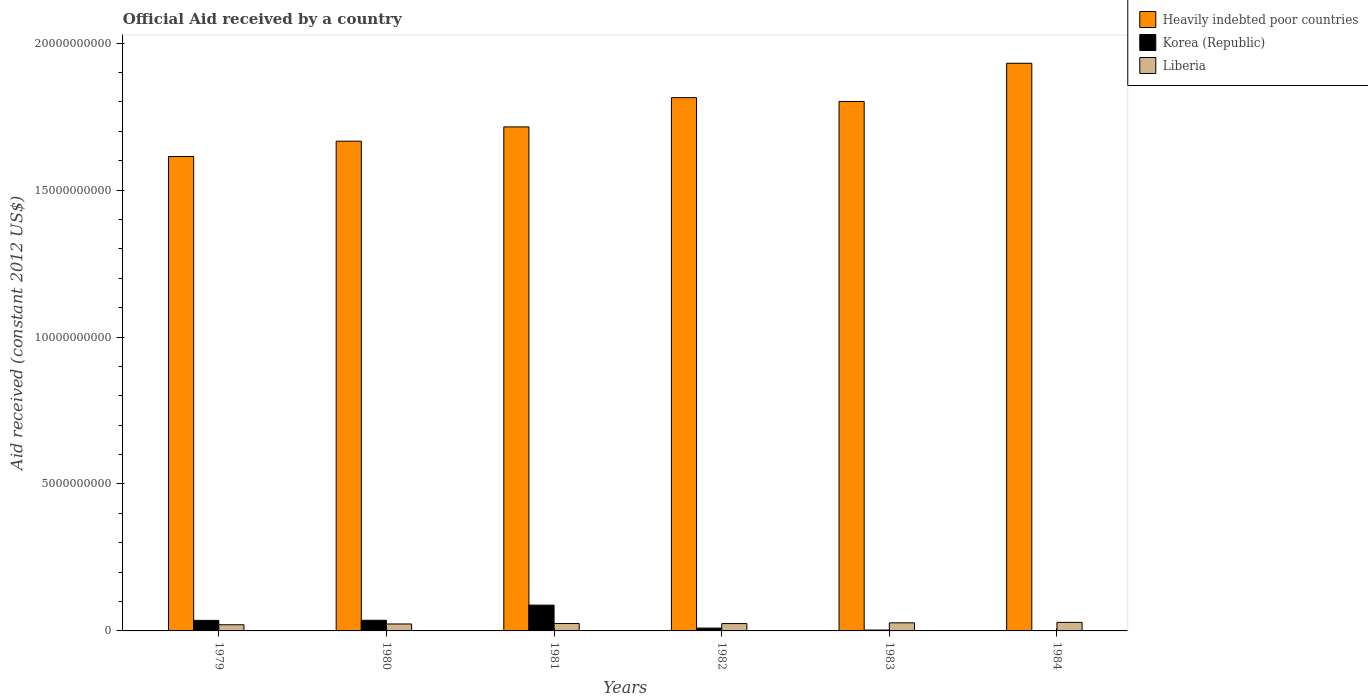How many groups of bars are there?
Provide a succinct answer. 6. Are the number of bars per tick equal to the number of legend labels?
Offer a very short reply. No. Are the number of bars on each tick of the X-axis equal?
Your answer should be compact. No. What is the net official aid received in Korea (Republic) in 1979?
Provide a succinct answer. 3.59e+08. Across all years, what is the maximum net official aid received in Heavily indebted poor countries?
Give a very brief answer. 1.93e+1. Across all years, what is the minimum net official aid received in Liberia?
Your answer should be compact. 2.09e+08. In which year was the net official aid received in Korea (Republic) maximum?
Make the answer very short. 1981. What is the total net official aid received in Heavily indebted poor countries in the graph?
Offer a very short reply. 1.05e+11. What is the difference between the net official aid received in Korea (Republic) in 1979 and that in 1980?
Your answer should be compact. -3.07e+06. What is the difference between the net official aid received in Korea (Republic) in 1981 and the net official aid received in Liberia in 1983?
Provide a short and direct response. 6.03e+08. What is the average net official aid received in Liberia per year?
Ensure brevity in your answer.  2.52e+08. In the year 1979, what is the difference between the net official aid received in Liberia and net official aid received in Korea (Republic)?
Make the answer very short. -1.50e+08. In how many years, is the net official aid received in Korea (Republic) greater than 15000000000 US$?
Your answer should be very brief. 0. What is the ratio of the net official aid received in Heavily indebted poor countries in 1979 to that in 1982?
Provide a short and direct response. 0.89. Is the net official aid received in Korea (Republic) in 1981 less than that in 1982?
Provide a short and direct response. No. Is the difference between the net official aid received in Liberia in 1980 and 1982 greater than the difference between the net official aid received in Korea (Republic) in 1980 and 1982?
Your response must be concise. No. What is the difference between the highest and the second highest net official aid received in Korea (Republic)?
Give a very brief answer. 5.16e+08. What is the difference between the highest and the lowest net official aid received in Korea (Republic)?
Provide a short and direct response. 8.78e+08. Is it the case that in every year, the sum of the net official aid received in Liberia and net official aid received in Korea (Republic) is greater than the net official aid received in Heavily indebted poor countries?
Give a very brief answer. No. How many bars are there?
Keep it short and to the point. 17. Are all the bars in the graph horizontal?
Offer a terse response. No. What is the difference between two consecutive major ticks on the Y-axis?
Give a very brief answer. 5.00e+09. How many legend labels are there?
Keep it short and to the point. 3. How are the legend labels stacked?
Your answer should be compact. Vertical. What is the title of the graph?
Provide a succinct answer. Official Aid received by a country. What is the label or title of the X-axis?
Keep it short and to the point. Years. What is the label or title of the Y-axis?
Offer a very short reply. Aid received (constant 2012 US$). What is the Aid received (constant 2012 US$) in Heavily indebted poor countries in 1979?
Offer a terse response. 1.61e+1. What is the Aid received (constant 2012 US$) in Korea (Republic) in 1979?
Offer a very short reply. 3.59e+08. What is the Aid received (constant 2012 US$) in Liberia in 1979?
Offer a very short reply. 2.09e+08. What is the Aid received (constant 2012 US$) in Heavily indebted poor countries in 1980?
Ensure brevity in your answer.  1.67e+1. What is the Aid received (constant 2012 US$) in Korea (Republic) in 1980?
Offer a very short reply. 3.62e+08. What is the Aid received (constant 2012 US$) of Liberia in 1980?
Your answer should be very brief. 2.36e+08. What is the Aid received (constant 2012 US$) in Heavily indebted poor countries in 1981?
Make the answer very short. 1.71e+1. What is the Aid received (constant 2012 US$) of Korea (Republic) in 1981?
Your response must be concise. 8.78e+08. What is the Aid received (constant 2012 US$) of Liberia in 1981?
Your answer should be compact. 2.51e+08. What is the Aid received (constant 2012 US$) of Heavily indebted poor countries in 1982?
Make the answer very short. 1.81e+1. What is the Aid received (constant 2012 US$) in Korea (Republic) in 1982?
Keep it short and to the point. 9.64e+07. What is the Aid received (constant 2012 US$) in Liberia in 1982?
Provide a short and direct response. 2.50e+08. What is the Aid received (constant 2012 US$) in Heavily indebted poor countries in 1983?
Your answer should be compact. 1.80e+1. What is the Aid received (constant 2012 US$) of Korea (Republic) in 1983?
Offer a terse response. 2.93e+07. What is the Aid received (constant 2012 US$) in Liberia in 1983?
Keep it short and to the point. 2.75e+08. What is the Aid received (constant 2012 US$) in Heavily indebted poor countries in 1984?
Keep it short and to the point. 1.93e+1. What is the Aid received (constant 2012 US$) in Liberia in 1984?
Offer a very short reply. 2.91e+08. Across all years, what is the maximum Aid received (constant 2012 US$) in Heavily indebted poor countries?
Give a very brief answer. 1.93e+1. Across all years, what is the maximum Aid received (constant 2012 US$) of Korea (Republic)?
Provide a short and direct response. 8.78e+08. Across all years, what is the maximum Aid received (constant 2012 US$) in Liberia?
Offer a very short reply. 2.91e+08. Across all years, what is the minimum Aid received (constant 2012 US$) of Heavily indebted poor countries?
Provide a succinct answer. 1.61e+1. Across all years, what is the minimum Aid received (constant 2012 US$) of Liberia?
Offer a very short reply. 2.09e+08. What is the total Aid received (constant 2012 US$) of Heavily indebted poor countries in the graph?
Provide a short and direct response. 1.05e+11. What is the total Aid received (constant 2012 US$) of Korea (Republic) in the graph?
Provide a short and direct response. 1.72e+09. What is the total Aid received (constant 2012 US$) of Liberia in the graph?
Ensure brevity in your answer.  1.51e+09. What is the difference between the Aid received (constant 2012 US$) in Heavily indebted poor countries in 1979 and that in 1980?
Your answer should be compact. -5.23e+08. What is the difference between the Aid received (constant 2012 US$) of Korea (Republic) in 1979 and that in 1980?
Provide a succinct answer. -3.07e+06. What is the difference between the Aid received (constant 2012 US$) of Liberia in 1979 and that in 1980?
Provide a short and direct response. -2.69e+07. What is the difference between the Aid received (constant 2012 US$) in Heavily indebted poor countries in 1979 and that in 1981?
Provide a short and direct response. -1.01e+09. What is the difference between the Aid received (constant 2012 US$) of Korea (Republic) in 1979 and that in 1981?
Offer a terse response. -5.19e+08. What is the difference between the Aid received (constant 2012 US$) of Liberia in 1979 and that in 1981?
Your answer should be very brief. -4.21e+07. What is the difference between the Aid received (constant 2012 US$) of Heavily indebted poor countries in 1979 and that in 1982?
Offer a terse response. -2.00e+09. What is the difference between the Aid received (constant 2012 US$) in Korea (Republic) in 1979 and that in 1982?
Make the answer very short. 2.63e+08. What is the difference between the Aid received (constant 2012 US$) of Liberia in 1979 and that in 1982?
Offer a very short reply. -4.05e+07. What is the difference between the Aid received (constant 2012 US$) in Heavily indebted poor countries in 1979 and that in 1983?
Offer a very short reply. -1.87e+09. What is the difference between the Aid received (constant 2012 US$) of Korea (Republic) in 1979 and that in 1983?
Ensure brevity in your answer.  3.30e+08. What is the difference between the Aid received (constant 2012 US$) of Liberia in 1979 and that in 1983?
Provide a succinct answer. -6.59e+07. What is the difference between the Aid received (constant 2012 US$) in Heavily indebted poor countries in 1979 and that in 1984?
Provide a succinct answer. -3.17e+09. What is the difference between the Aid received (constant 2012 US$) in Liberia in 1979 and that in 1984?
Provide a succinct answer. -8.14e+07. What is the difference between the Aid received (constant 2012 US$) in Heavily indebted poor countries in 1980 and that in 1981?
Your answer should be compact. -4.85e+08. What is the difference between the Aid received (constant 2012 US$) in Korea (Republic) in 1980 and that in 1981?
Your answer should be very brief. -5.16e+08. What is the difference between the Aid received (constant 2012 US$) of Liberia in 1980 and that in 1981?
Your answer should be very brief. -1.52e+07. What is the difference between the Aid received (constant 2012 US$) of Heavily indebted poor countries in 1980 and that in 1982?
Provide a succinct answer. -1.48e+09. What is the difference between the Aid received (constant 2012 US$) of Korea (Republic) in 1980 and that in 1982?
Your answer should be compact. 2.66e+08. What is the difference between the Aid received (constant 2012 US$) in Liberia in 1980 and that in 1982?
Give a very brief answer. -1.35e+07. What is the difference between the Aid received (constant 2012 US$) of Heavily indebted poor countries in 1980 and that in 1983?
Ensure brevity in your answer.  -1.35e+09. What is the difference between the Aid received (constant 2012 US$) of Korea (Republic) in 1980 and that in 1983?
Provide a succinct answer. 3.33e+08. What is the difference between the Aid received (constant 2012 US$) of Liberia in 1980 and that in 1983?
Your answer should be very brief. -3.89e+07. What is the difference between the Aid received (constant 2012 US$) of Heavily indebted poor countries in 1980 and that in 1984?
Keep it short and to the point. -2.65e+09. What is the difference between the Aid received (constant 2012 US$) in Liberia in 1980 and that in 1984?
Your answer should be compact. -5.45e+07. What is the difference between the Aid received (constant 2012 US$) in Heavily indebted poor countries in 1981 and that in 1982?
Your answer should be compact. -9.95e+08. What is the difference between the Aid received (constant 2012 US$) in Korea (Republic) in 1981 and that in 1982?
Ensure brevity in your answer.  7.81e+08. What is the difference between the Aid received (constant 2012 US$) in Liberia in 1981 and that in 1982?
Provide a short and direct response. 1.65e+06. What is the difference between the Aid received (constant 2012 US$) of Heavily indebted poor countries in 1981 and that in 1983?
Offer a very short reply. -8.65e+08. What is the difference between the Aid received (constant 2012 US$) in Korea (Republic) in 1981 and that in 1983?
Ensure brevity in your answer.  8.49e+08. What is the difference between the Aid received (constant 2012 US$) of Liberia in 1981 and that in 1983?
Provide a short and direct response. -2.38e+07. What is the difference between the Aid received (constant 2012 US$) of Heavily indebted poor countries in 1981 and that in 1984?
Give a very brief answer. -2.17e+09. What is the difference between the Aid received (constant 2012 US$) of Liberia in 1981 and that in 1984?
Offer a very short reply. -3.93e+07. What is the difference between the Aid received (constant 2012 US$) of Heavily indebted poor countries in 1982 and that in 1983?
Provide a succinct answer. 1.30e+08. What is the difference between the Aid received (constant 2012 US$) in Korea (Republic) in 1982 and that in 1983?
Ensure brevity in your answer.  6.71e+07. What is the difference between the Aid received (constant 2012 US$) in Liberia in 1982 and that in 1983?
Your answer should be very brief. -2.54e+07. What is the difference between the Aid received (constant 2012 US$) in Heavily indebted poor countries in 1982 and that in 1984?
Your answer should be compact. -1.17e+09. What is the difference between the Aid received (constant 2012 US$) of Liberia in 1982 and that in 1984?
Your answer should be very brief. -4.09e+07. What is the difference between the Aid received (constant 2012 US$) in Heavily indebted poor countries in 1983 and that in 1984?
Offer a terse response. -1.30e+09. What is the difference between the Aid received (constant 2012 US$) in Liberia in 1983 and that in 1984?
Your response must be concise. -1.55e+07. What is the difference between the Aid received (constant 2012 US$) of Heavily indebted poor countries in 1979 and the Aid received (constant 2012 US$) of Korea (Republic) in 1980?
Offer a very short reply. 1.58e+1. What is the difference between the Aid received (constant 2012 US$) in Heavily indebted poor countries in 1979 and the Aid received (constant 2012 US$) in Liberia in 1980?
Offer a terse response. 1.59e+1. What is the difference between the Aid received (constant 2012 US$) in Korea (Republic) in 1979 and the Aid received (constant 2012 US$) in Liberia in 1980?
Provide a short and direct response. 1.23e+08. What is the difference between the Aid received (constant 2012 US$) of Heavily indebted poor countries in 1979 and the Aid received (constant 2012 US$) of Korea (Republic) in 1981?
Ensure brevity in your answer.  1.53e+1. What is the difference between the Aid received (constant 2012 US$) in Heavily indebted poor countries in 1979 and the Aid received (constant 2012 US$) in Liberia in 1981?
Provide a succinct answer. 1.59e+1. What is the difference between the Aid received (constant 2012 US$) of Korea (Republic) in 1979 and the Aid received (constant 2012 US$) of Liberia in 1981?
Provide a succinct answer. 1.08e+08. What is the difference between the Aid received (constant 2012 US$) of Heavily indebted poor countries in 1979 and the Aid received (constant 2012 US$) of Korea (Republic) in 1982?
Your answer should be compact. 1.60e+1. What is the difference between the Aid received (constant 2012 US$) in Heavily indebted poor countries in 1979 and the Aid received (constant 2012 US$) in Liberia in 1982?
Ensure brevity in your answer.  1.59e+1. What is the difference between the Aid received (constant 2012 US$) in Korea (Republic) in 1979 and the Aid received (constant 2012 US$) in Liberia in 1982?
Make the answer very short. 1.09e+08. What is the difference between the Aid received (constant 2012 US$) of Heavily indebted poor countries in 1979 and the Aid received (constant 2012 US$) of Korea (Republic) in 1983?
Offer a very short reply. 1.61e+1. What is the difference between the Aid received (constant 2012 US$) in Heavily indebted poor countries in 1979 and the Aid received (constant 2012 US$) in Liberia in 1983?
Keep it short and to the point. 1.59e+1. What is the difference between the Aid received (constant 2012 US$) in Korea (Republic) in 1979 and the Aid received (constant 2012 US$) in Liberia in 1983?
Keep it short and to the point. 8.39e+07. What is the difference between the Aid received (constant 2012 US$) in Heavily indebted poor countries in 1979 and the Aid received (constant 2012 US$) in Liberia in 1984?
Your answer should be very brief. 1.58e+1. What is the difference between the Aid received (constant 2012 US$) of Korea (Republic) in 1979 and the Aid received (constant 2012 US$) of Liberia in 1984?
Offer a very short reply. 6.84e+07. What is the difference between the Aid received (constant 2012 US$) in Heavily indebted poor countries in 1980 and the Aid received (constant 2012 US$) in Korea (Republic) in 1981?
Your answer should be compact. 1.58e+1. What is the difference between the Aid received (constant 2012 US$) in Heavily indebted poor countries in 1980 and the Aid received (constant 2012 US$) in Liberia in 1981?
Ensure brevity in your answer.  1.64e+1. What is the difference between the Aid received (constant 2012 US$) in Korea (Republic) in 1980 and the Aid received (constant 2012 US$) in Liberia in 1981?
Your response must be concise. 1.11e+08. What is the difference between the Aid received (constant 2012 US$) in Heavily indebted poor countries in 1980 and the Aid received (constant 2012 US$) in Korea (Republic) in 1982?
Your response must be concise. 1.66e+1. What is the difference between the Aid received (constant 2012 US$) in Heavily indebted poor countries in 1980 and the Aid received (constant 2012 US$) in Liberia in 1982?
Your response must be concise. 1.64e+1. What is the difference between the Aid received (constant 2012 US$) in Korea (Republic) in 1980 and the Aid received (constant 2012 US$) in Liberia in 1982?
Your answer should be very brief. 1.12e+08. What is the difference between the Aid received (constant 2012 US$) in Heavily indebted poor countries in 1980 and the Aid received (constant 2012 US$) in Korea (Republic) in 1983?
Provide a short and direct response. 1.66e+1. What is the difference between the Aid received (constant 2012 US$) of Heavily indebted poor countries in 1980 and the Aid received (constant 2012 US$) of Liberia in 1983?
Your answer should be compact. 1.64e+1. What is the difference between the Aid received (constant 2012 US$) in Korea (Republic) in 1980 and the Aid received (constant 2012 US$) in Liberia in 1983?
Ensure brevity in your answer.  8.70e+07. What is the difference between the Aid received (constant 2012 US$) of Heavily indebted poor countries in 1980 and the Aid received (constant 2012 US$) of Liberia in 1984?
Your answer should be compact. 1.64e+1. What is the difference between the Aid received (constant 2012 US$) of Korea (Republic) in 1980 and the Aid received (constant 2012 US$) of Liberia in 1984?
Offer a terse response. 7.15e+07. What is the difference between the Aid received (constant 2012 US$) of Heavily indebted poor countries in 1981 and the Aid received (constant 2012 US$) of Korea (Republic) in 1982?
Provide a succinct answer. 1.71e+1. What is the difference between the Aid received (constant 2012 US$) of Heavily indebted poor countries in 1981 and the Aid received (constant 2012 US$) of Liberia in 1982?
Offer a terse response. 1.69e+1. What is the difference between the Aid received (constant 2012 US$) of Korea (Republic) in 1981 and the Aid received (constant 2012 US$) of Liberia in 1982?
Provide a succinct answer. 6.28e+08. What is the difference between the Aid received (constant 2012 US$) of Heavily indebted poor countries in 1981 and the Aid received (constant 2012 US$) of Korea (Republic) in 1983?
Offer a very short reply. 1.71e+1. What is the difference between the Aid received (constant 2012 US$) of Heavily indebted poor countries in 1981 and the Aid received (constant 2012 US$) of Liberia in 1983?
Make the answer very short. 1.69e+1. What is the difference between the Aid received (constant 2012 US$) of Korea (Republic) in 1981 and the Aid received (constant 2012 US$) of Liberia in 1983?
Your response must be concise. 6.03e+08. What is the difference between the Aid received (constant 2012 US$) in Heavily indebted poor countries in 1981 and the Aid received (constant 2012 US$) in Liberia in 1984?
Ensure brevity in your answer.  1.69e+1. What is the difference between the Aid received (constant 2012 US$) of Korea (Republic) in 1981 and the Aid received (constant 2012 US$) of Liberia in 1984?
Give a very brief answer. 5.87e+08. What is the difference between the Aid received (constant 2012 US$) in Heavily indebted poor countries in 1982 and the Aid received (constant 2012 US$) in Korea (Republic) in 1983?
Provide a succinct answer. 1.81e+1. What is the difference between the Aid received (constant 2012 US$) of Heavily indebted poor countries in 1982 and the Aid received (constant 2012 US$) of Liberia in 1983?
Offer a terse response. 1.79e+1. What is the difference between the Aid received (constant 2012 US$) of Korea (Republic) in 1982 and the Aid received (constant 2012 US$) of Liberia in 1983?
Your answer should be very brief. -1.79e+08. What is the difference between the Aid received (constant 2012 US$) in Heavily indebted poor countries in 1982 and the Aid received (constant 2012 US$) in Liberia in 1984?
Your answer should be very brief. 1.79e+1. What is the difference between the Aid received (constant 2012 US$) in Korea (Republic) in 1982 and the Aid received (constant 2012 US$) in Liberia in 1984?
Your response must be concise. -1.94e+08. What is the difference between the Aid received (constant 2012 US$) in Heavily indebted poor countries in 1983 and the Aid received (constant 2012 US$) in Liberia in 1984?
Ensure brevity in your answer.  1.77e+1. What is the difference between the Aid received (constant 2012 US$) of Korea (Republic) in 1983 and the Aid received (constant 2012 US$) of Liberia in 1984?
Ensure brevity in your answer.  -2.61e+08. What is the average Aid received (constant 2012 US$) in Heavily indebted poor countries per year?
Ensure brevity in your answer.  1.76e+1. What is the average Aid received (constant 2012 US$) in Korea (Republic) per year?
Give a very brief answer. 2.87e+08. What is the average Aid received (constant 2012 US$) in Liberia per year?
Keep it short and to the point. 2.52e+08. In the year 1979, what is the difference between the Aid received (constant 2012 US$) in Heavily indebted poor countries and Aid received (constant 2012 US$) in Korea (Republic)?
Your response must be concise. 1.58e+1. In the year 1979, what is the difference between the Aid received (constant 2012 US$) in Heavily indebted poor countries and Aid received (constant 2012 US$) in Liberia?
Your response must be concise. 1.59e+1. In the year 1979, what is the difference between the Aid received (constant 2012 US$) in Korea (Republic) and Aid received (constant 2012 US$) in Liberia?
Make the answer very short. 1.50e+08. In the year 1980, what is the difference between the Aid received (constant 2012 US$) of Heavily indebted poor countries and Aid received (constant 2012 US$) of Korea (Republic)?
Ensure brevity in your answer.  1.63e+1. In the year 1980, what is the difference between the Aid received (constant 2012 US$) of Heavily indebted poor countries and Aid received (constant 2012 US$) of Liberia?
Ensure brevity in your answer.  1.64e+1. In the year 1980, what is the difference between the Aid received (constant 2012 US$) of Korea (Republic) and Aid received (constant 2012 US$) of Liberia?
Provide a succinct answer. 1.26e+08. In the year 1981, what is the difference between the Aid received (constant 2012 US$) of Heavily indebted poor countries and Aid received (constant 2012 US$) of Korea (Republic)?
Your answer should be very brief. 1.63e+1. In the year 1981, what is the difference between the Aid received (constant 2012 US$) of Heavily indebted poor countries and Aid received (constant 2012 US$) of Liberia?
Provide a short and direct response. 1.69e+1. In the year 1981, what is the difference between the Aid received (constant 2012 US$) of Korea (Republic) and Aid received (constant 2012 US$) of Liberia?
Keep it short and to the point. 6.27e+08. In the year 1982, what is the difference between the Aid received (constant 2012 US$) in Heavily indebted poor countries and Aid received (constant 2012 US$) in Korea (Republic)?
Provide a short and direct response. 1.80e+1. In the year 1982, what is the difference between the Aid received (constant 2012 US$) of Heavily indebted poor countries and Aid received (constant 2012 US$) of Liberia?
Offer a terse response. 1.79e+1. In the year 1982, what is the difference between the Aid received (constant 2012 US$) in Korea (Republic) and Aid received (constant 2012 US$) in Liberia?
Your response must be concise. -1.53e+08. In the year 1983, what is the difference between the Aid received (constant 2012 US$) in Heavily indebted poor countries and Aid received (constant 2012 US$) in Korea (Republic)?
Offer a very short reply. 1.80e+1. In the year 1983, what is the difference between the Aid received (constant 2012 US$) in Heavily indebted poor countries and Aid received (constant 2012 US$) in Liberia?
Provide a succinct answer. 1.77e+1. In the year 1983, what is the difference between the Aid received (constant 2012 US$) of Korea (Republic) and Aid received (constant 2012 US$) of Liberia?
Give a very brief answer. -2.46e+08. In the year 1984, what is the difference between the Aid received (constant 2012 US$) of Heavily indebted poor countries and Aid received (constant 2012 US$) of Liberia?
Keep it short and to the point. 1.90e+1. What is the ratio of the Aid received (constant 2012 US$) in Heavily indebted poor countries in 1979 to that in 1980?
Provide a short and direct response. 0.97. What is the ratio of the Aid received (constant 2012 US$) in Korea (Republic) in 1979 to that in 1980?
Your answer should be very brief. 0.99. What is the ratio of the Aid received (constant 2012 US$) of Liberia in 1979 to that in 1980?
Provide a short and direct response. 0.89. What is the ratio of the Aid received (constant 2012 US$) in Korea (Republic) in 1979 to that in 1981?
Your response must be concise. 0.41. What is the ratio of the Aid received (constant 2012 US$) of Liberia in 1979 to that in 1981?
Offer a very short reply. 0.83. What is the ratio of the Aid received (constant 2012 US$) in Heavily indebted poor countries in 1979 to that in 1982?
Give a very brief answer. 0.89. What is the ratio of the Aid received (constant 2012 US$) in Korea (Republic) in 1979 to that in 1982?
Your response must be concise. 3.72. What is the ratio of the Aid received (constant 2012 US$) in Liberia in 1979 to that in 1982?
Make the answer very short. 0.84. What is the ratio of the Aid received (constant 2012 US$) in Heavily indebted poor countries in 1979 to that in 1983?
Keep it short and to the point. 0.9. What is the ratio of the Aid received (constant 2012 US$) in Korea (Republic) in 1979 to that in 1983?
Keep it short and to the point. 12.25. What is the ratio of the Aid received (constant 2012 US$) of Liberia in 1979 to that in 1983?
Your answer should be compact. 0.76. What is the ratio of the Aid received (constant 2012 US$) in Heavily indebted poor countries in 1979 to that in 1984?
Make the answer very short. 0.84. What is the ratio of the Aid received (constant 2012 US$) in Liberia in 1979 to that in 1984?
Your answer should be very brief. 0.72. What is the ratio of the Aid received (constant 2012 US$) in Heavily indebted poor countries in 1980 to that in 1981?
Your response must be concise. 0.97. What is the ratio of the Aid received (constant 2012 US$) of Korea (Republic) in 1980 to that in 1981?
Offer a very short reply. 0.41. What is the ratio of the Aid received (constant 2012 US$) in Liberia in 1980 to that in 1981?
Give a very brief answer. 0.94. What is the ratio of the Aid received (constant 2012 US$) in Heavily indebted poor countries in 1980 to that in 1982?
Ensure brevity in your answer.  0.92. What is the ratio of the Aid received (constant 2012 US$) of Korea (Republic) in 1980 to that in 1982?
Offer a terse response. 3.76. What is the ratio of the Aid received (constant 2012 US$) in Liberia in 1980 to that in 1982?
Your response must be concise. 0.95. What is the ratio of the Aid received (constant 2012 US$) of Heavily indebted poor countries in 1980 to that in 1983?
Offer a very short reply. 0.93. What is the ratio of the Aid received (constant 2012 US$) in Korea (Republic) in 1980 to that in 1983?
Make the answer very short. 12.35. What is the ratio of the Aid received (constant 2012 US$) in Liberia in 1980 to that in 1983?
Ensure brevity in your answer.  0.86. What is the ratio of the Aid received (constant 2012 US$) in Heavily indebted poor countries in 1980 to that in 1984?
Your answer should be very brief. 0.86. What is the ratio of the Aid received (constant 2012 US$) in Liberia in 1980 to that in 1984?
Provide a succinct answer. 0.81. What is the ratio of the Aid received (constant 2012 US$) of Heavily indebted poor countries in 1981 to that in 1982?
Your response must be concise. 0.95. What is the ratio of the Aid received (constant 2012 US$) of Korea (Republic) in 1981 to that in 1982?
Ensure brevity in your answer.  9.11. What is the ratio of the Aid received (constant 2012 US$) in Liberia in 1981 to that in 1982?
Offer a very short reply. 1.01. What is the ratio of the Aid received (constant 2012 US$) of Korea (Republic) in 1981 to that in 1983?
Offer a very short reply. 29.95. What is the ratio of the Aid received (constant 2012 US$) of Liberia in 1981 to that in 1983?
Offer a very short reply. 0.91. What is the ratio of the Aid received (constant 2012 US$) of Heavily indebted poor countries in 1981 to that in 1984?
Your answer should be compact. 0.89. What is the ratio of the Aid received (constant 2012 US$) of Liberia in 1981 to that in 1984?
Offer a very short reply. 0.86. What is the ratio of the Aid received (constant 2012 US$) of Korea (Republic) in 1982 to that in 1983?
Make the answer very short. 3.29. What is the ratio of the Aid received (constant 2012 US$) of Liberia in 1982 to that in 1983?
Keep it short and to the point. 0.91. What is the ratio of the Aid received (constant 2012 US$) in Heavily indebted poor countries in 1982 to that in 1984?
Offer a very short reply. 0.94. What is the ratio of the Aid received (constant 2012 US$) in Liberia in 1982 to that in 1984?
Your answer should be very brief. 0.86. What is the ratio of the Aid received (constant 2012 US$) in Heavily indebted poor countries in 1983 to that in 1984?
Offer a terse response. 0.93. What is the ratio of the Aid received (constant 2012 US$) of Liberia in 1983 to that in 1984?
Provide a short and direct response. 0.95. What is the difference between the highest and the second highest Aid received (constant 2012 US$) in Heavily indebted poor countries?
Make the answer very short. 1.17e+09. What is the difference between the highest and the second highest Aid received (constant 2012 US$) in Korea (Republic)?
Ensure brevity in your answer.  5.16e+08. What is the difference between the highest and the second highest Aid received (constant 2012 US$) of Liberia?
Make the answer very short. 1.55e+07. What is the difference between the highest and the lowest Aid received (constant 2012 US$) in Heavily indebted poor countries?
Your answer should be very brief. 3.17e+09. What is the difference between the highest and the lowest Aid received (constant 2012 US$) in Korea (Republic)?
Keep it short and to the point. 8.78e+08. What is the difference between the highest and the lowest Aid received (constant 2012 US$) in Liberia?
Your answer should be very brief. 8.14e+07. 